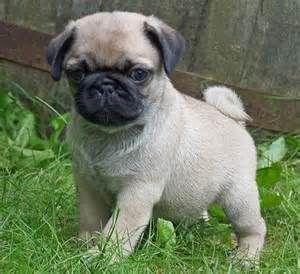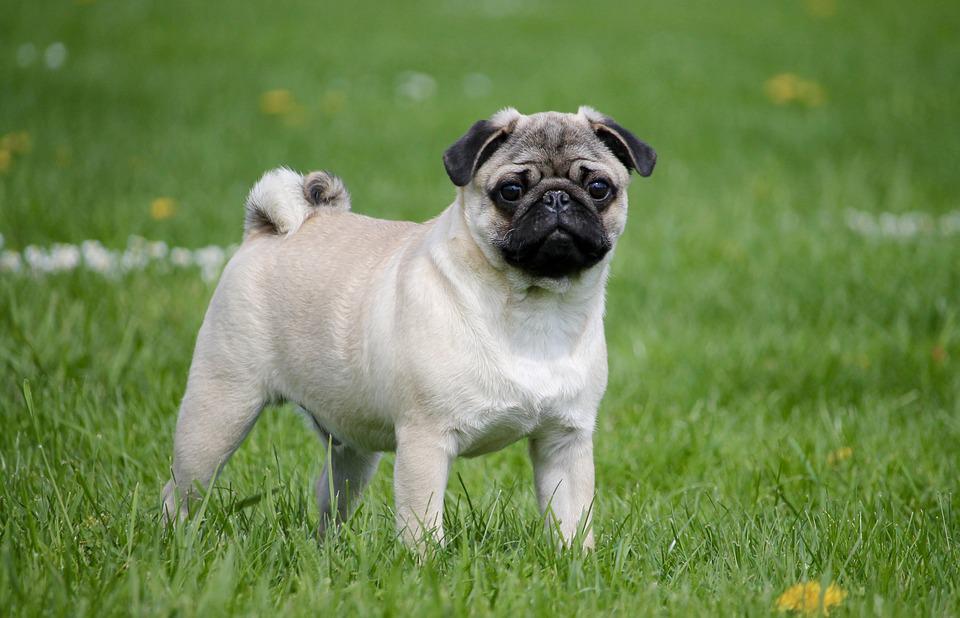The first image is the image on the left, the second image is the image on the right. Examine the images to the left and right. Is the description "At least one dog has a visible collar." accurate? Answer yes or no. No. 